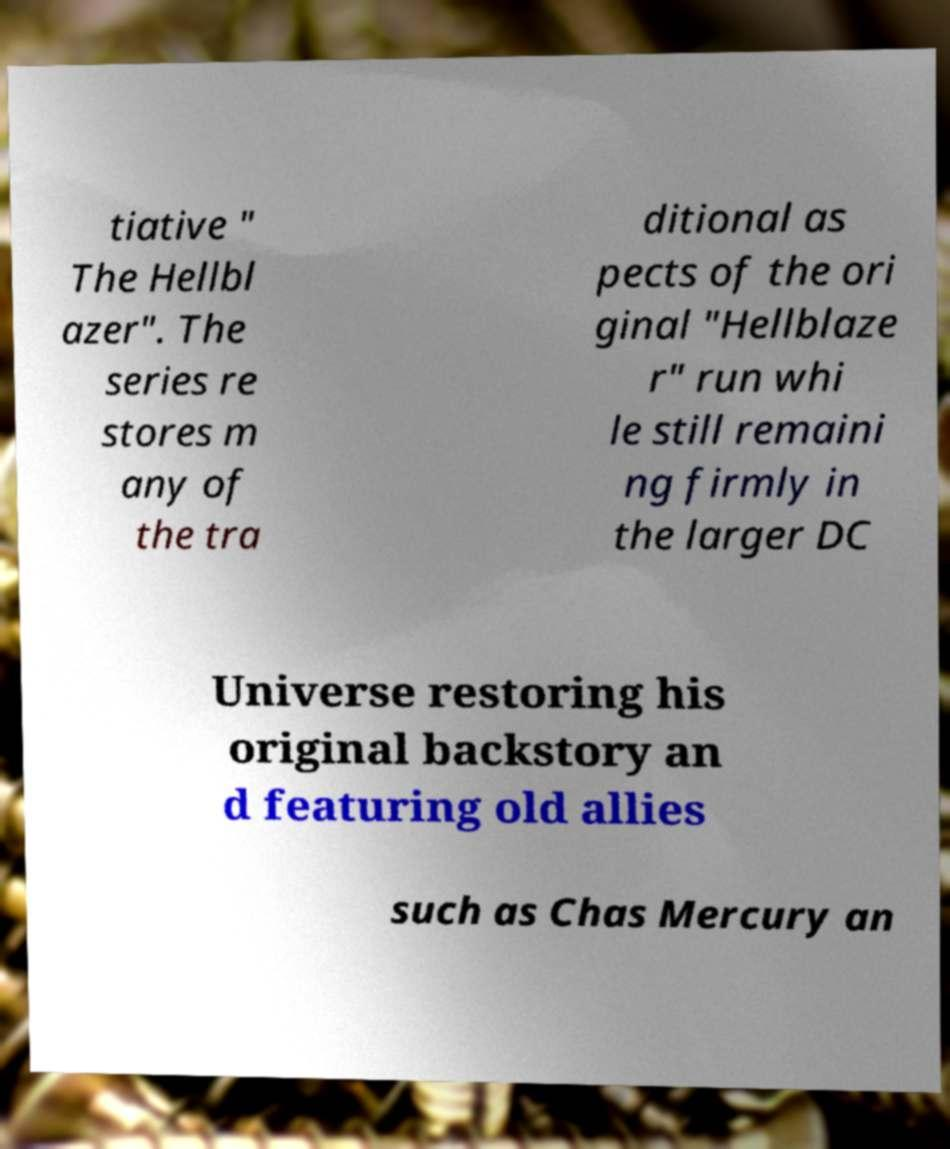What messages or text are displayed in this image? I need them in a readable, typed format. tiative " The Hellbl azer". The series re stores m any of the tra ditional as pects of the ori ginal "Hellblaze r" run whi le still remaini ng firmly in the larger DC Universe restoring his original backstory an d featuring old allies such as Chas Mercury an 